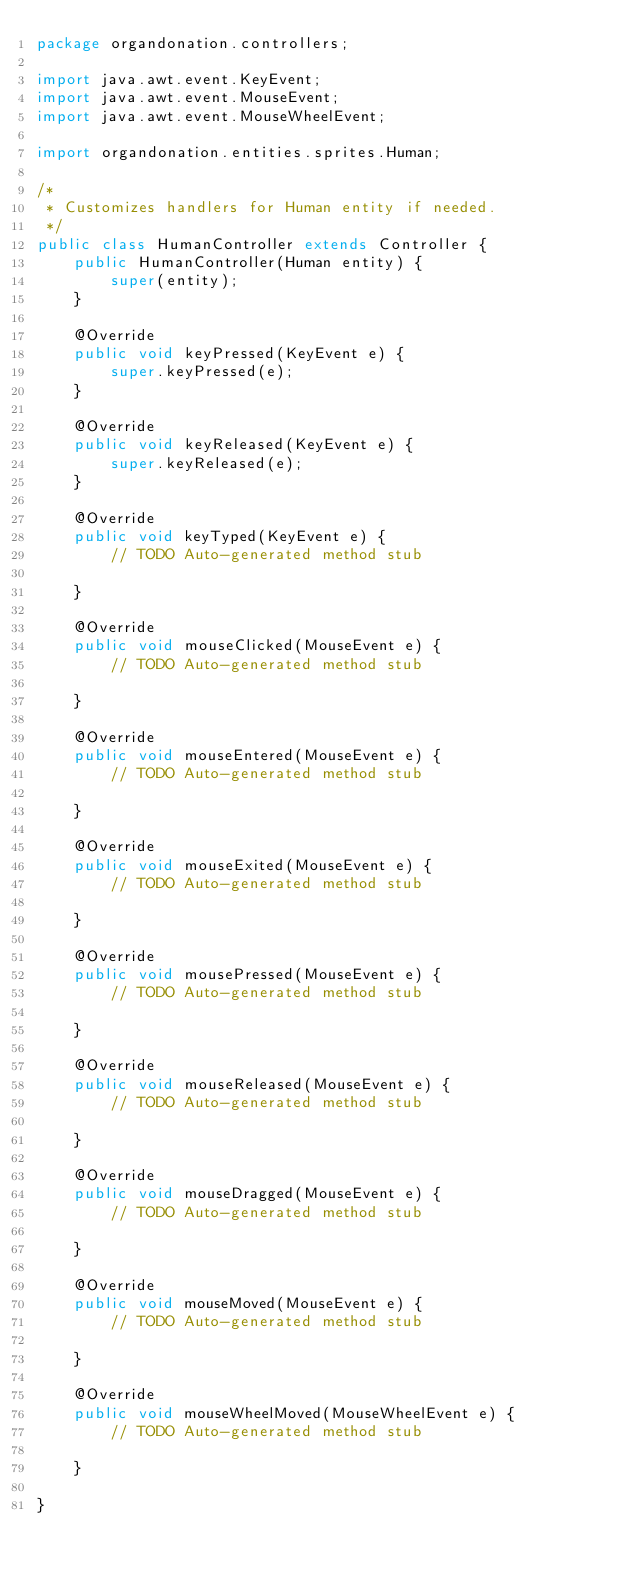Convert code to text. <code><loc_0><loc_0><loc_500><loc_500><_Java_>package organdonation.controllers;

import java.awt.event.KeyEvent;
import java.awt.event.MouseEvent;
import java.awt.event.MouseWheelEvent;

import organdonation.entities.sprites.Human;

/*
 * Customizes handlers for Human entity if needed.
 */
public class HumanController extends Controller {
	public HumanController(Human entity) {
		super(entity);
	}

	@Override
	public void keyPressed(KeyEvent e) {
		super.keyPressed(e);
	}

	@Override
	public void keyReleased(KeyEvent e) {
		super.keyReleased(e);
	}

	@Override
	public void keyTyped(KeyEvent e) {
		// TODO Auto-generated method stub

	}

	@Override
	public void mouseClicked(MouseEvent e) {
		// TODO Auto-generated method stub

	}

	@Override
	public void mouseEntered(MouseEvent e) {
		// TODO Auto-generated method stub

	}

	@Override
	public void mouseExited(MouseEvent e) {
		// TODO Auto-generated method stub

	}

	@Override
	public void mousePressed(MouseEvent e) {
		// TODO Auto-generated method stub

	}

	@Override
	public void mouseReleased(MouseEvent e) {
		// TODO Auto-generated method stub

	}

	@Override
	public void mouseDragged(MouseEvent e) {
		// TODO Auto-generated method stub

	}

	@Override
	public void mouseMoved(MouseEvent e) {
		// TODO Auto-generated method stub

	}

	@Override
	public void mouseWheelMoved(MouseWheelEvent e) {
		// TODO Auto-generated method stub

	}

}
</code> 